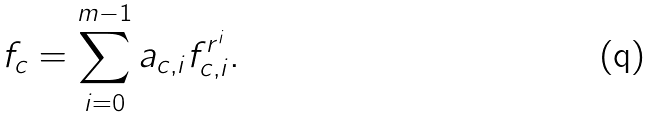Convert formula to latex. <formula><loc_0><loc_0><loc_500><loc_500>f _ { c } = \sum _ { i = 0 } ^ { m - 1 } a _ { c , i } f _ { c , i } ^ { r ^ { i } } .</formula> 